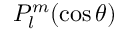Convert formula to latex. <formula><loc_0><loc_0><loc_500><loc_500>P _ { l } ^ { m } ( \cos \theta )</formula> 